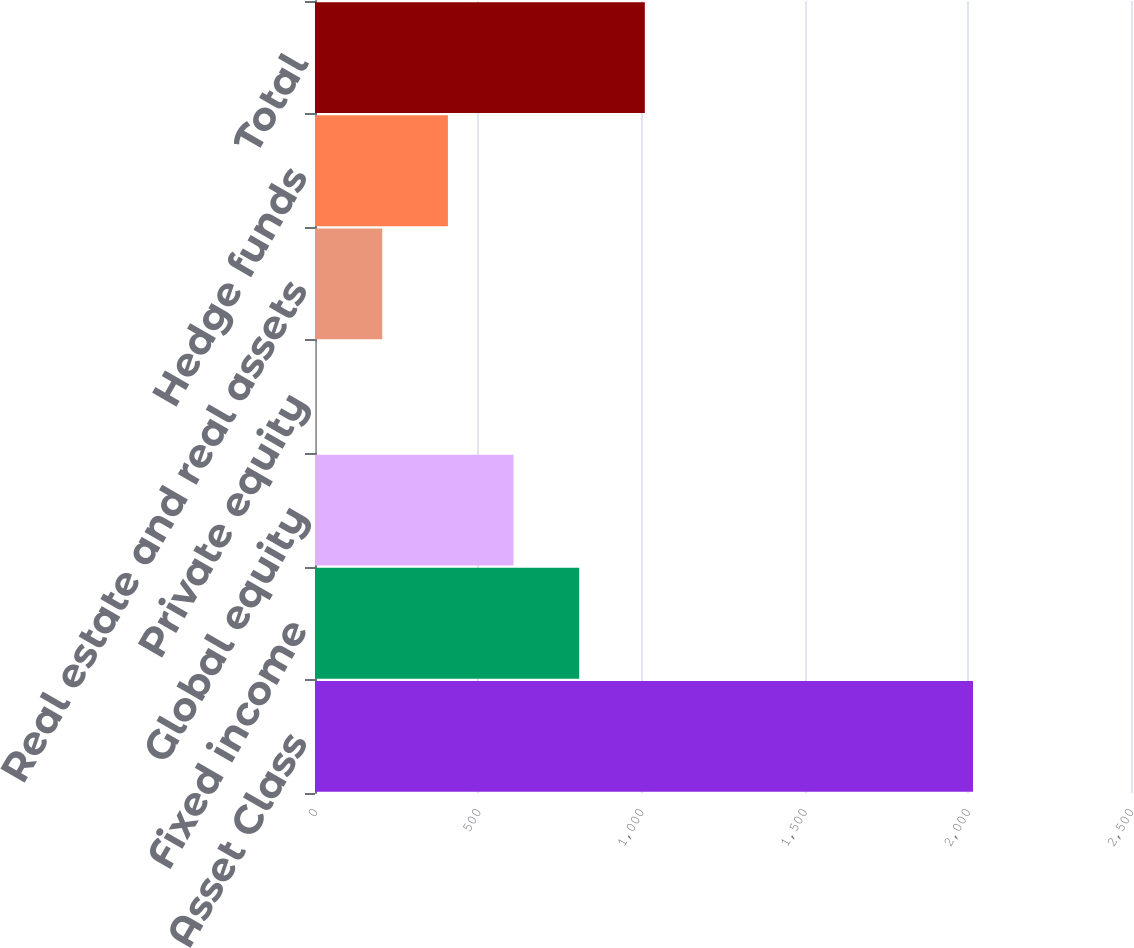Convert chart. <chart><loc_0><loc_0><loc_500><loc_500><bar_chart><fcel>Asset Class<fcel>Fixed income<fcel>Global equity<fcel>Private equity<fcel>Real estate and real assets<fcel>Hedge funds<fcel>Total<nl><fcel>2016<fcel>809.4<fcel>608.3<fcel>5<fcel>206.1<fcel>407.2<fcel>1010.5<nl></chart> 